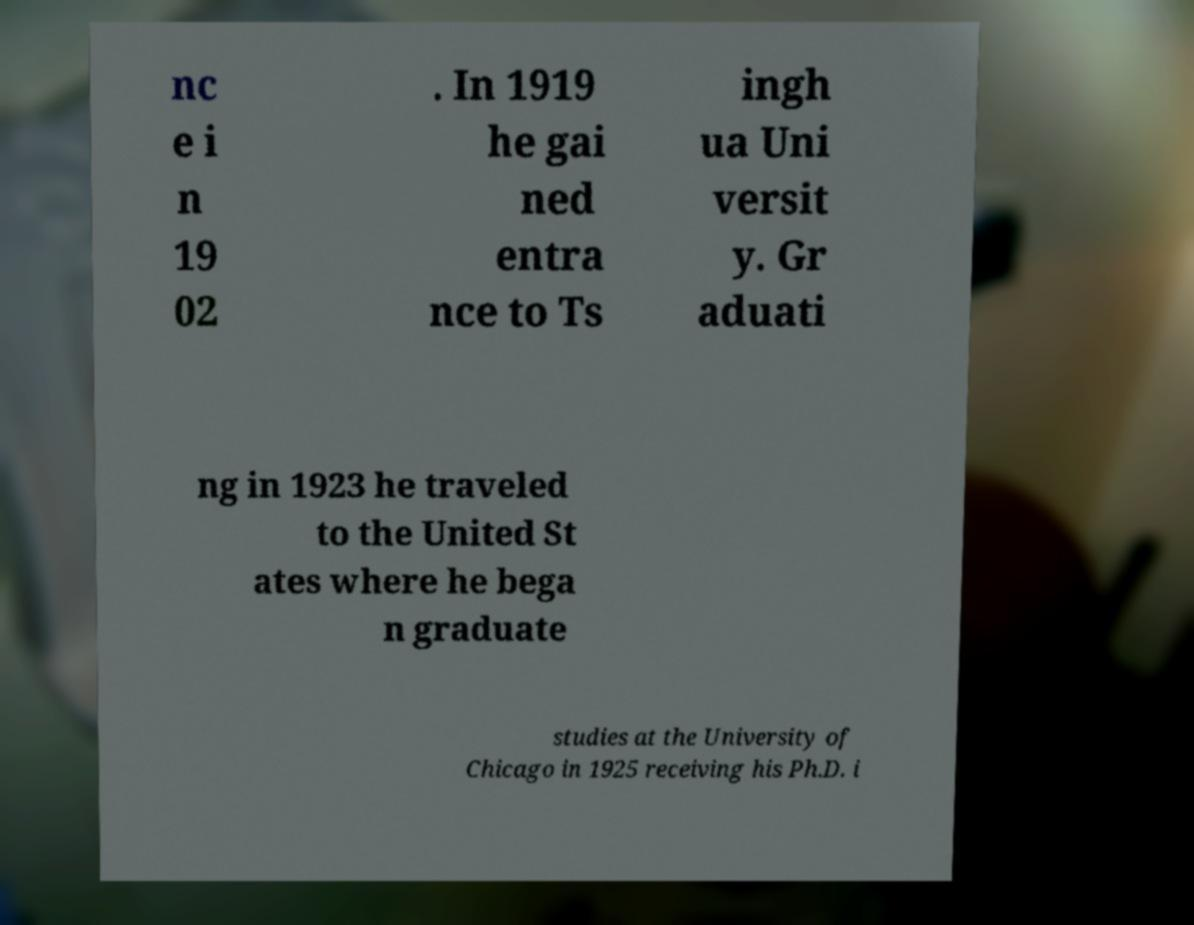Please identify and transcribe the text found in this image. nc e i n 19 02 . In 1919 he gai ned entra nce to Ts ingh ua Uni versit y. Gr aduati ng in 1923 he traveled to the United St ates where he bega n graduate studies at the University of Chicago in 1925 receiving his Ph.D. i 